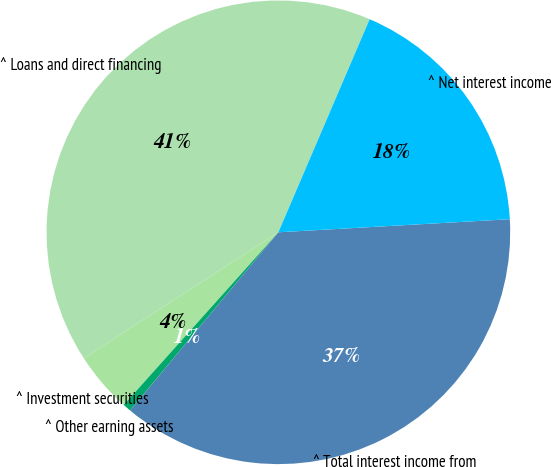Convert chart. <chart><loc_0><loc_0><loc_500><loc_500><pie_chart><fcel>^ Loans and direct financing<fcel>^ Investment securities<fcel>^ Other earning assets<fcel>^ Total interest income from<fcel>^ Net interest income<nl><fcel>40.59%<fcel>4.23%<fcel>0.58%<fcel>36.95%<fcel>17.66%<nl></chart> 